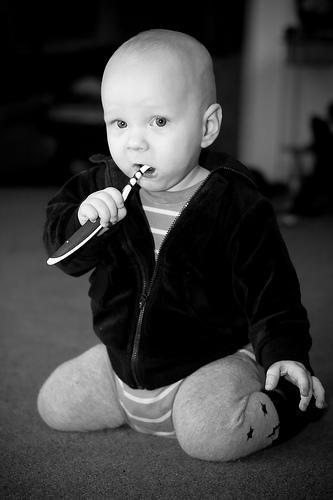How many people do you see in this picture?
Give a very brief answer. 1. 